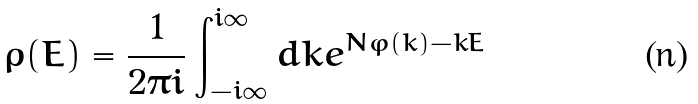<formula> <loc_0><loc_0><loc_500><loc_500>\rho ( E ) = \frac { 1 } { 2 \pi i } \int _ { - i \infty } ^ { i \infty } d k e ^ { N \varphi ( k ) - k E }</formula> 